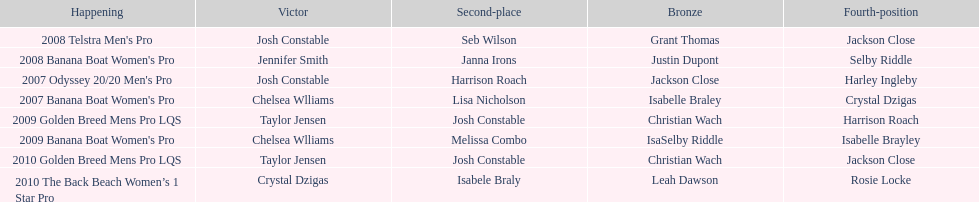In what event did chelsea williams win her first title? 2007 Banana Boat Women's Pro. 